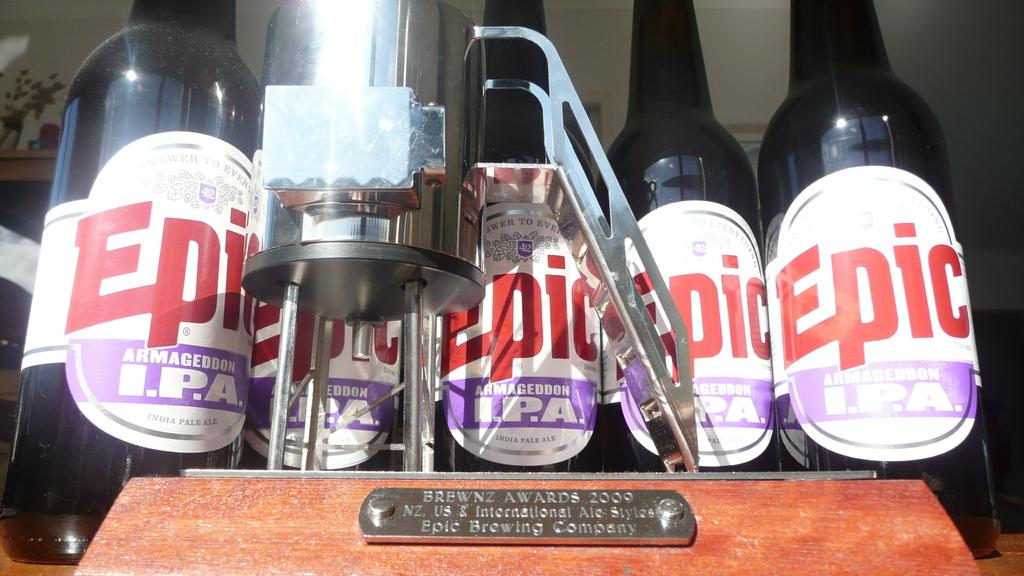<image>
Present a compact description of the photo's key features. Bottles of Epic sit side by side behind an award. 